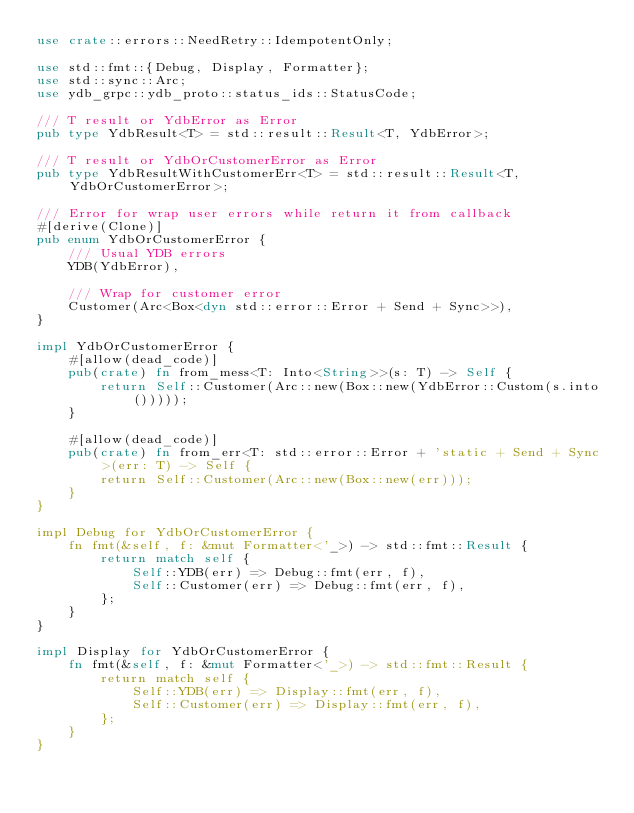<code> <loc_0><loc_0><loc_500><loc_500><_Rust_>use crate::errors::NeedRetry::IdempotentOnly;

use std::fmt::{Debug, Display, Formatter};
use std::sync::Arc;
use ydb_grpc::ydb_proto::status_ids::StatusCode;

/// T result or YdbError as Error
pub type YdbResult<T> = std::result::Result<T, YdbError>;

/// T result or YdbOrCustomerError as Error
pub type YdbResultWithCustomerErr<T> = std::result::Result<T, YdbOrCustomerError>;

/// Error for wrap user errors while return it from callback
#[derive(Clone)]
pub enum YdbOrCustomerError {
    /// Usual YDB errors
    YDB(YdbError),

    /// Wrap for customer error
    Customer(Arc<Box<dyn std::error::Error + Send + Sync>>),
}

impl YdbOrCustomerError {
    #[allow(dead_code)]
    pub(crate) fn from_mess<T: Into<String>>(s: T) -> Self {
        return Self::Customer(Arc::new(Box::new(YdbError::Custom(s.into()))));
    }

    #[allow(dead_code)]
    pub(crate) fn from_err<T: std::error::Error + 'static + Send + Sync>(err: T) -> Self {
        return Self::Customer(Arc::new(Box::new(err)));
    }
}

impl Debug for YdbOrCustomerError {
    fn fmt(&self, f: &mut Formatter<'_>) -> std::fmt::Result {
        return match self {
            Self::YDB(err) => Debug::fmt(err, f),
            Self::Customer(err) => Debug::fmt(err, f),
        };
    }
}

impl Display for YdbOrCustomerError {
    fn fmt(&self, f: &mut Formatter<'_>) -> std::fmt::Result {
        return match self {
            Self::YDB(err) => Display::fmt(err, f),
            Self::Customer(err) => Display::fmt(err, f),
        };
    }
}
</code> 